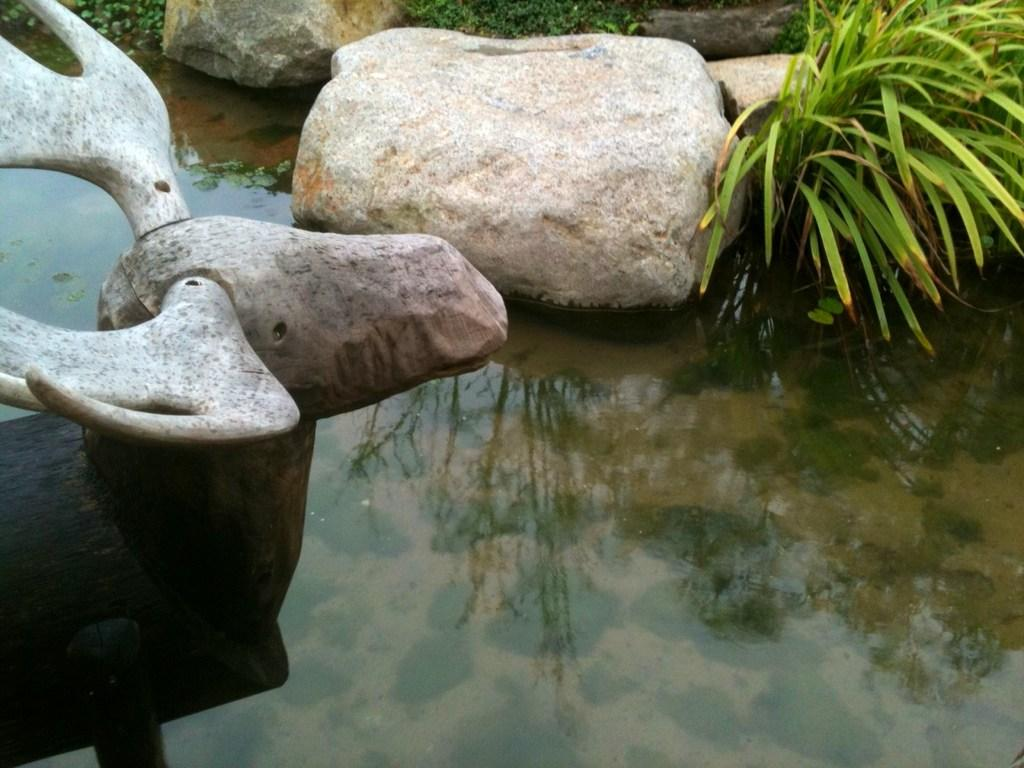What type of natural elements can be seen in the image? There are stones and grass visible in the image. What is the presence of water in the image indicative of? The presence of water in the image suggests that there might be a body of water or a water source nearby. Can you describe the stone carving in the image? There is a stone carving of an animal in the image. What type of trees can be seen in the image? There are no trees visible in the image. Can you hear the sound of a flame in the image? There is no sound or flame present in the image. 